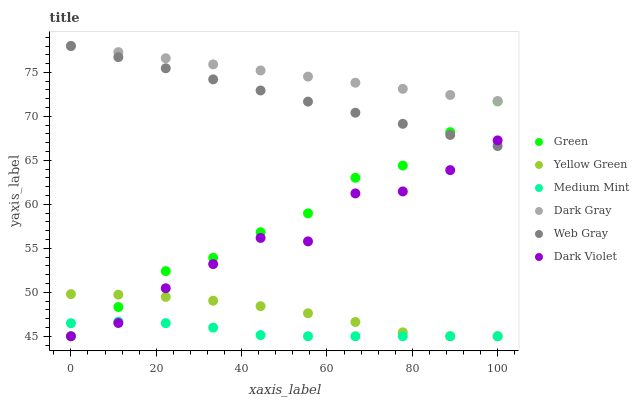Does Medium Mint have the minimum area under the curve?
Answer yes or no. Yes. Does Dark Gray have the maximum area under the curve?
Answer yes or no. Yes. Does Web Gray have the minimum area under the curve?
Answer yes or no. No. Does Web Gray have the maximum area under the curve?
Answer yes or no. No. Is Web Gray the smoothest?
Answer yes or no. Yes. Is Dark Violet the roughest?
Answer yes or no. Yes. Is Yellow Green the smoothest?
Answer yes or no. No. Is Yellow Green the roughest?
Answer yes or no. No. Does Medium Mint have the lowest value?
Answer yes or no. Yes. Does Web Gray have the lowest value?
Answer yes or no. No. Does Dark Gray have the highest value?
Answer yes or no. Yes. Does Yellow Green have the highest value?
Answer yes or no. No. Is Yellow Green less than Dark Gray?
Answer yes or no. Yes. Is Green greater than Dark Violet?
Answer yes or no. Yes. Does Web Gray intersect Dark Gray?
Answer yes or no. Yes. Is Web Gray less than Dark Gray?
Answer yes or no. No. Is Web Gray greater than Dark Gray?
Answer yes or no. No. Does Yellow Green intersect Dark Gray?
Answer yes or no. No. 